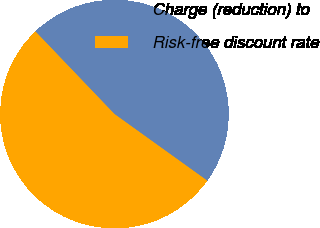<chart> <loc_0><loc_0><loc_500><loc_500><pie_chart><fcel>Charge (reduction) to<fcel>Risk-free discount rate<nl><fcel>47.06%<fcel>52.94%<nl></chart> 